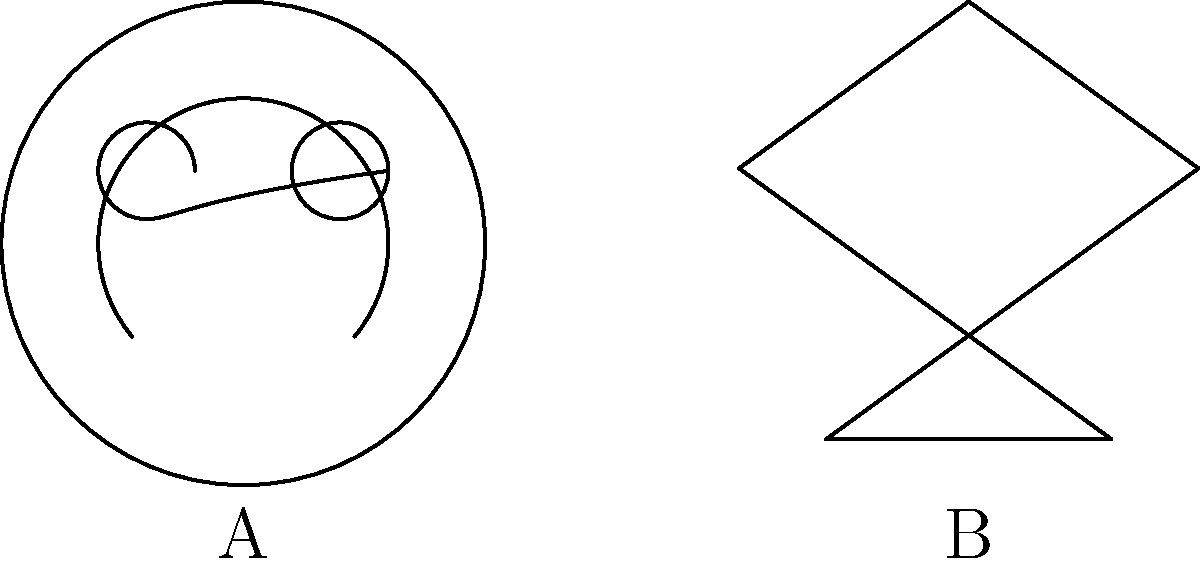Consider the two cartoon character shapes shown above: a smiley face (A) and a star (B). What is the genus of each shape, and how does this affect their topological properties? To determine the genus and topological properties of these shapes, let's analyze them step-by-step:

1. Smiley Face (A):
   a. The overall shape is a circle (the face outline).
   b. It has two circular holes for eyes.
   c. The mouth is not a hole, as it doesn't penetrate the surface.

   Genus calculation:
   - A sphere has genus 0.
   - Each hole increases the genus by 1.
   - The smiley face has 2 holes (eyes).
   
   Therefore, the genus of the smiley face is 2.

2. Star Shape (B):
   a. The star is a simple closed curve with no holes.
   b. Topologically, it's equivalent to a circle.

   Genus calculation:
   - A circle (or any shape topologically equivalent to it) has genus 0.

   Therefore, the genus of the star is 0.

Topological properties:
- The smiley face (genus 2) is not homeomorphic to a sphere or a plane. It's topologically equivalent to a sphere with two handles or a donut with an extra hole.
- The star (genus 0) is homeomorphic to a circle and can be continuously deformed into any simple closed curve without holes.

In animation, these properties affect how the shapes can be manipulated:
- The smiley face can't be smoothly transformed into a star without closing the eye holes.
- The star can be smoothly deformed into any other simple closed shape without holes, like a circle or a square.
Answer: Smiley face: genus 2; Star: genus 0. Smiley face is topologically equivalent to a sphere with two handles, while the star is homeomorphic to a circle. 